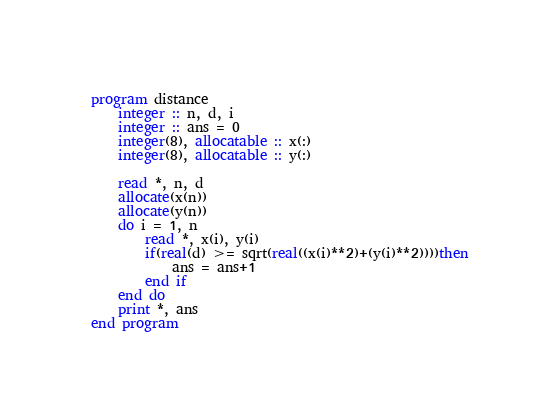Convert code to text. <code><loc_0><loc_0><loc_500><loc_500><_FORTRAN_>program distance
    integer :: n, d, i
    integer :: ans = 0
    integer(8), allocatable :: x(:)
    integer(8), allocatable :: y(:)

    read *, n, d
    allocate(x(n))
    allocate(y(n))
    do i = 1, n
        read *, x(i), y(i)
        if(real(d) >= sqrt(real((x(i)**2)+(y(i)**2))))then
            ans = ans+1
        end if
    end do
    print *, ans
end program</code> 